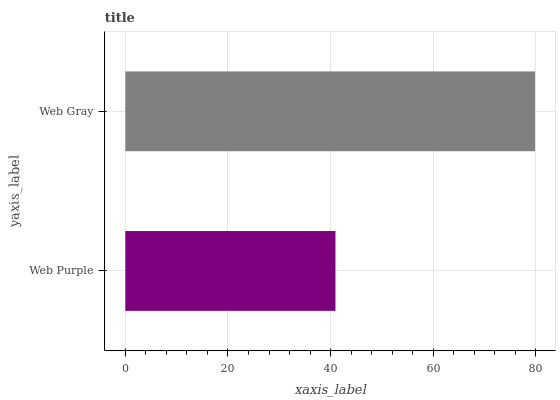Is Web Purple the minimum?
Answer yes or no. Yes. Is Web Gray the maximum?
Answer yes or no. Yes. Is Web Gray the minimum?
Answer yes or no. No. Is Web Gray greater than Web Purple?
Answer yes or no. Yes. Is Web Purple less than Web Gray?
Answer yes or no. Yes. Is Web Purple greater than Web Gray?
Answer yes or no. No. Is Web Gray less than Web Purple?
Answer yes or no. No. Is Web Gray the high median?
Answer yes or no. Yes. Is Web Purple the low median?
Answer yes or no. Yes. Is Web Purple the high median?
Answer yes or no. No. Is Web Gray the low median?
Answer yes or no. No. 